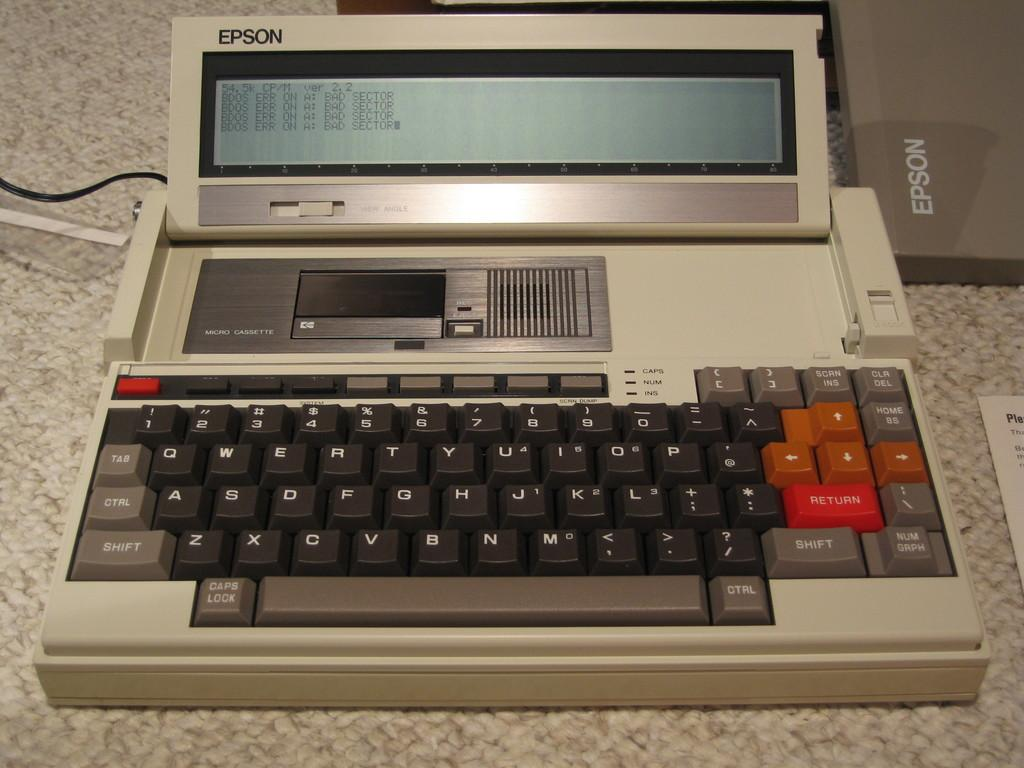<image>
Give a short and clear explanation of the subsequent image. Many years ago, Epson used to manufacture computers. 